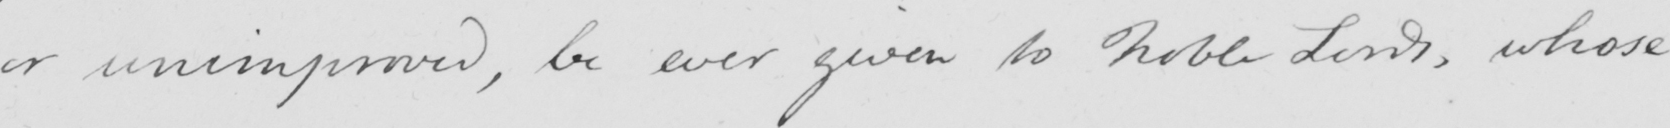What is written in this line of handwriting? or unimproved, be ever given to Noble Lords, whose 